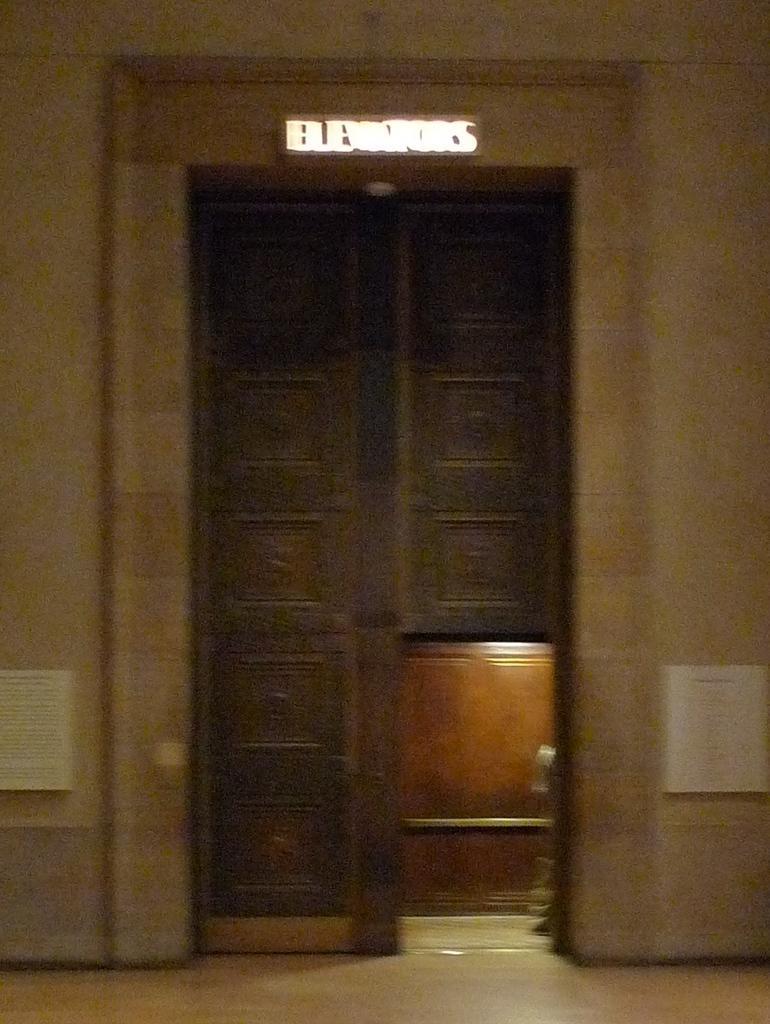How would you summarize this image in a sentence or two? In this picture there is a door in the center of the image. 